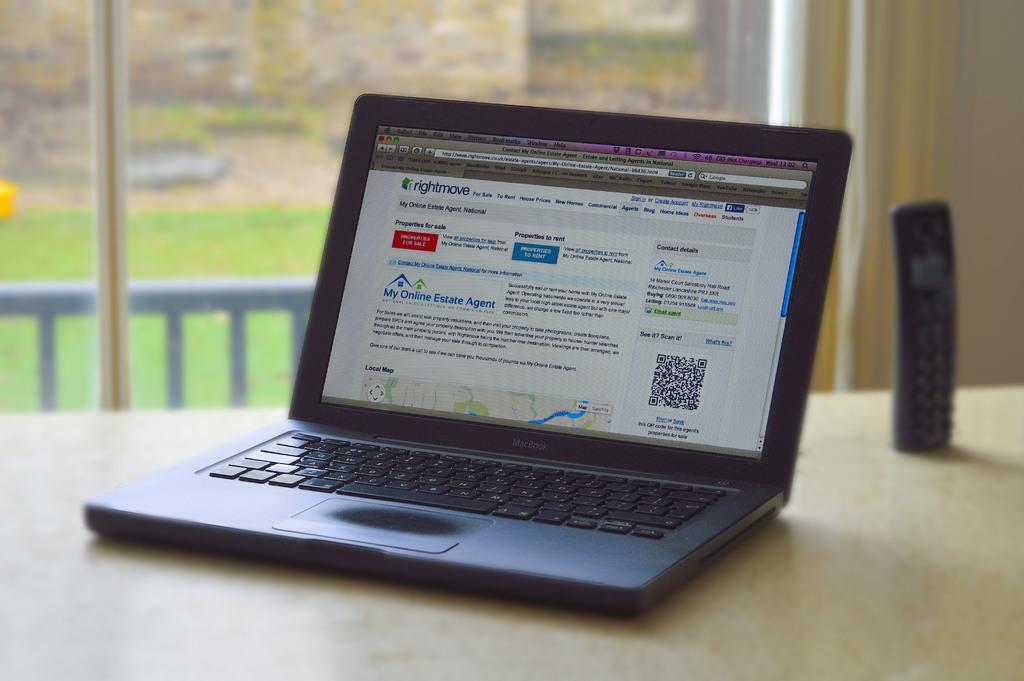What business is it?
Provide a short and direct response. Rightmove. Is that the top of a local map or a national map on the laptop screen?
Keep it short and to the point. Local. 